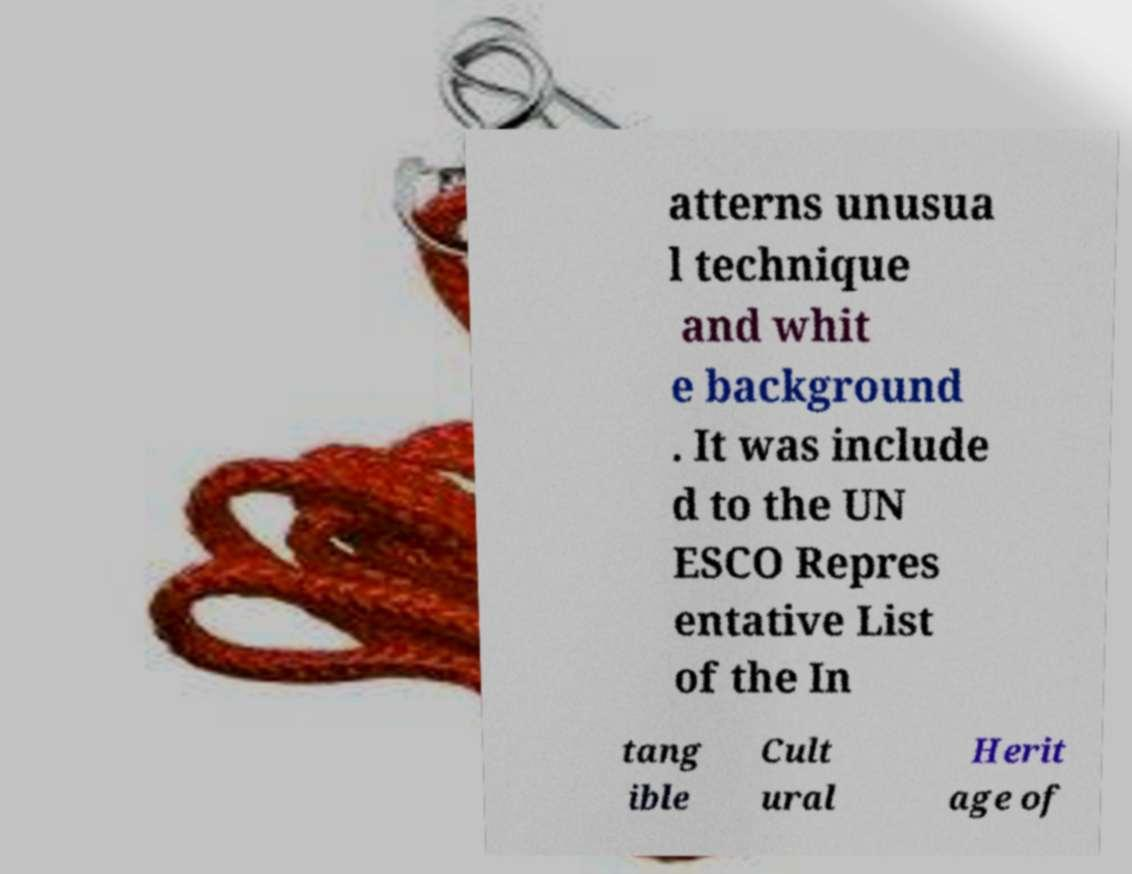There's text embedded in this image that I need extracted. Can you transcribe it verbatim? atterns unusua l technique and whit e background . It was include d to the UN ESCO Repres entative List of the In tang ible Cult ural Herit age of 